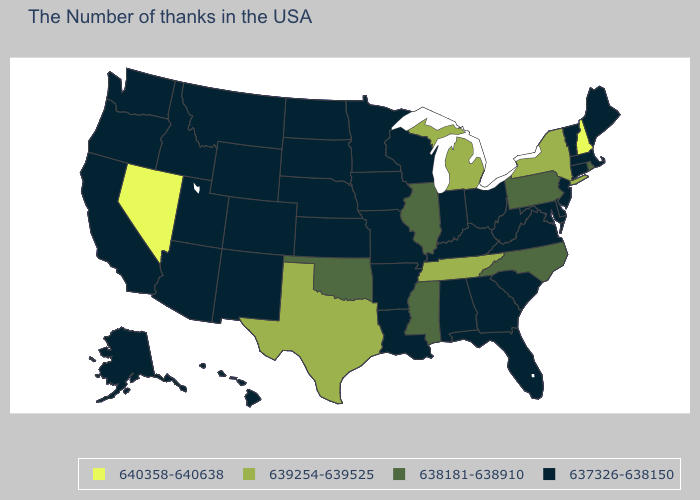What is the highest value in the USA?
Answer briefly. 640358-640638. What is the highest value in the Northeast ?
Quick response, please. 640358-640638. Does the first symbol in the legend represent the smallest category?
Quick response, please. No. What is the value of South Carolina?
Quick response, please. 637326-638150. What is the value of Florida?
Be succinct. 637326-638150. Does New Hampshire have the same value as Kentucky?
Concise answer only. No. Among the states that border New Mexico , does Texas have the highest value?
Give a very brief answer. Yes. What is the value of Colorado?
Short answer required. 637326-638150. Among the states that border Oregon , does Washington have the lowest value?
Quick response, please. Yes. Name the states that have a value in the range 639254-639525?
Be succinct. New York, Michigan, Tennessee, Texas. Does the first symbol in the legend represent the smallest category?
Write a very short answer. No. What is the value of Washington?
Answer briefly. 637326-638150. Among the states that border Virginia , does Maryland have the lowest value?
Keep it brief. Yes. Name the states that have a value in the range 638181-638910?
Be succinct. Rhode Island, Pennsylvania, North Carolina, Illinois, Mississippi, Oklahoma. How many symbols are there in the legend?
Answer briefly. 4. 